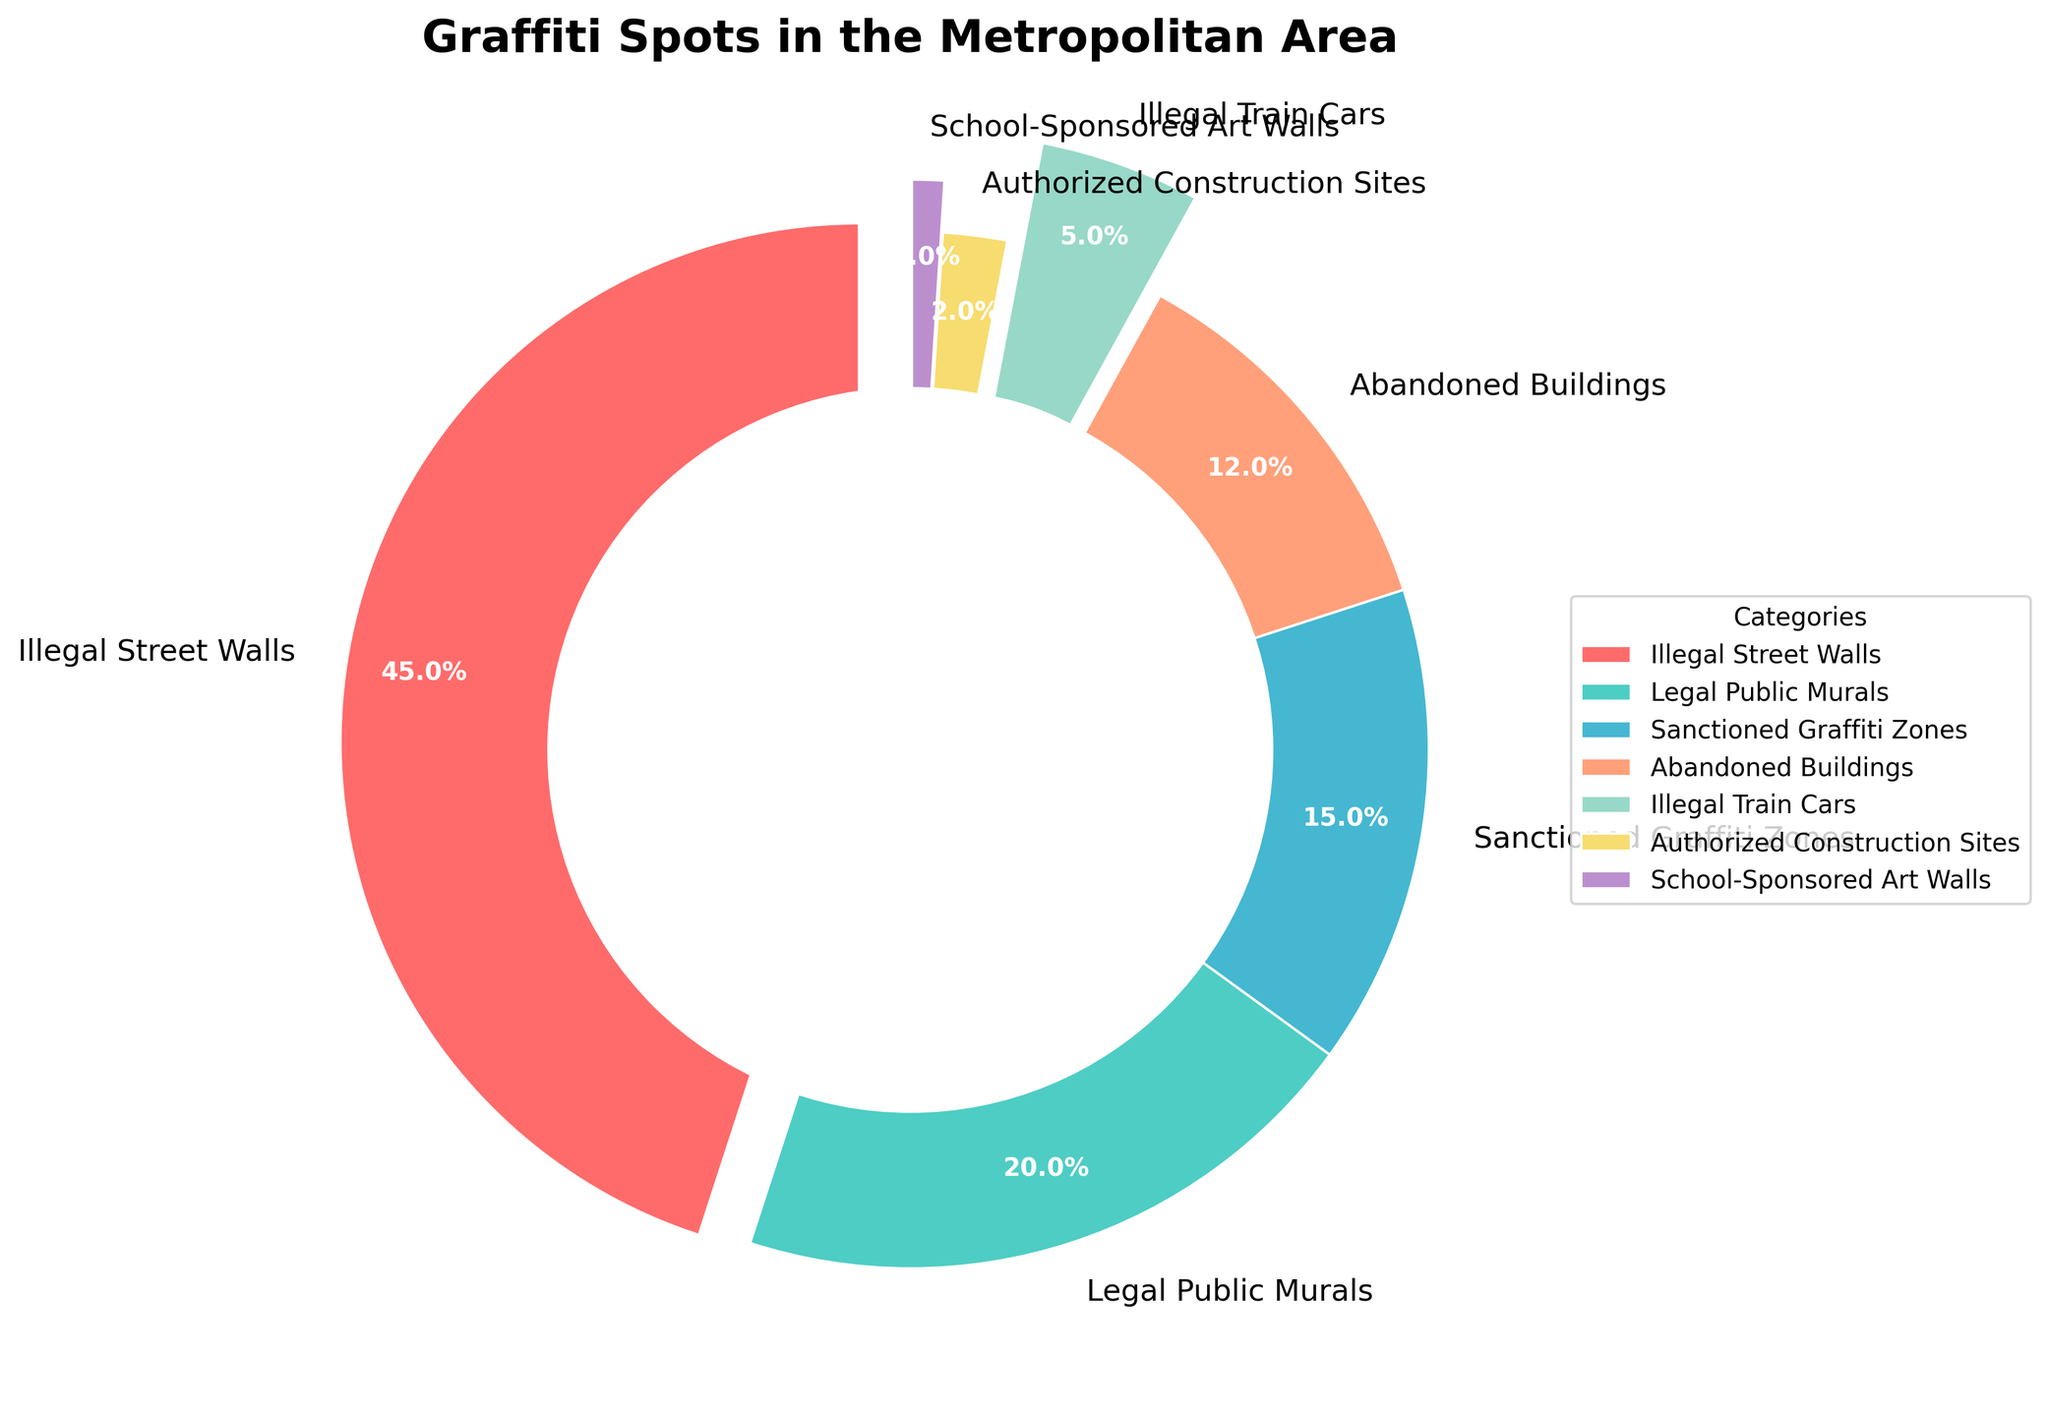What's the combined percentage of legal graffiti spots? Legal graffiti spots include 'Legal Public Murals', 'Sanctioned Graffiti Zones', 'Authorized Construction Sites', and 'School-Sponsored Art Walls'. Adding up their percentages: 20 + 15 + 2 + 1 = 38%.
Answer: 38% Which category has the smallest proportion of graffiti spots? Looking at the pie chart, 'School-Sponsored Art Walls' have the smallest proportion with only 1%.
Answer: School-Sponsored Art Walls Are there more illegal or legal graffiti spots? Illegal spots are 'Illegal Street Walls' (45%) and 'Illegal Train Cars' (5%), totaling 45 + 5 = 50%. Legal spots total 38%. Since 50% > 38%, there are more illegal graffiti spots.
Answer: Illegal graffiti spots What is the difference in percentage between Illegal Street Walls and Sanctioned Graffiti Zones? Illegal Street Walls make up 45%, while Sanctioned Graffiti Zones make up 15%. The difference is 45 - 15 = 30%.
Answer: 30% Which two categories combined make up over 50% of the graffiti spots? 'Illegal Street Walls' (45%) and 'Legal Public Murals' (20%) combined make up 65%, which is over 50%.
Answer: Illegal Street Walls and Legal Public Murals What proportion of the graffiti spots are located on train cars? Analyzing the segment labeled 'Illegal Train Cars', it makes up 5% of the pie chart.
Answer: 5% How many more percentage points do Illegal Street Walls account for compared to Abandoned Buildings? Illegal Street Walls account for 45%, and Abandoned Buildings account for 12%. The difference is 45 - 12 = 33 percentage points.
Answer: 33 percentage points Is the proportion of Legal Public Murals greater than that of Sanctioned Graffiti Zones and Abandoned Buildings combined? Legal Public Murals account for 20%. Sanctioned Graffiti Zones (15%) + Abandoned Buildings (12%) = 27%. Since 20 < 27, Legal Public Murals are not greater.
Answer: No Which category is represented visually with a larger segment than Abandoned Buildings but a smaller one than Legal Public Murals? 'Sanctioned Graffiti Zones' is larger than Abandoned Buildings (15% > 12%) and smaller than Legal Public Murals (15% < 20%).
Answer: Sanctioned Graffiti Zones 